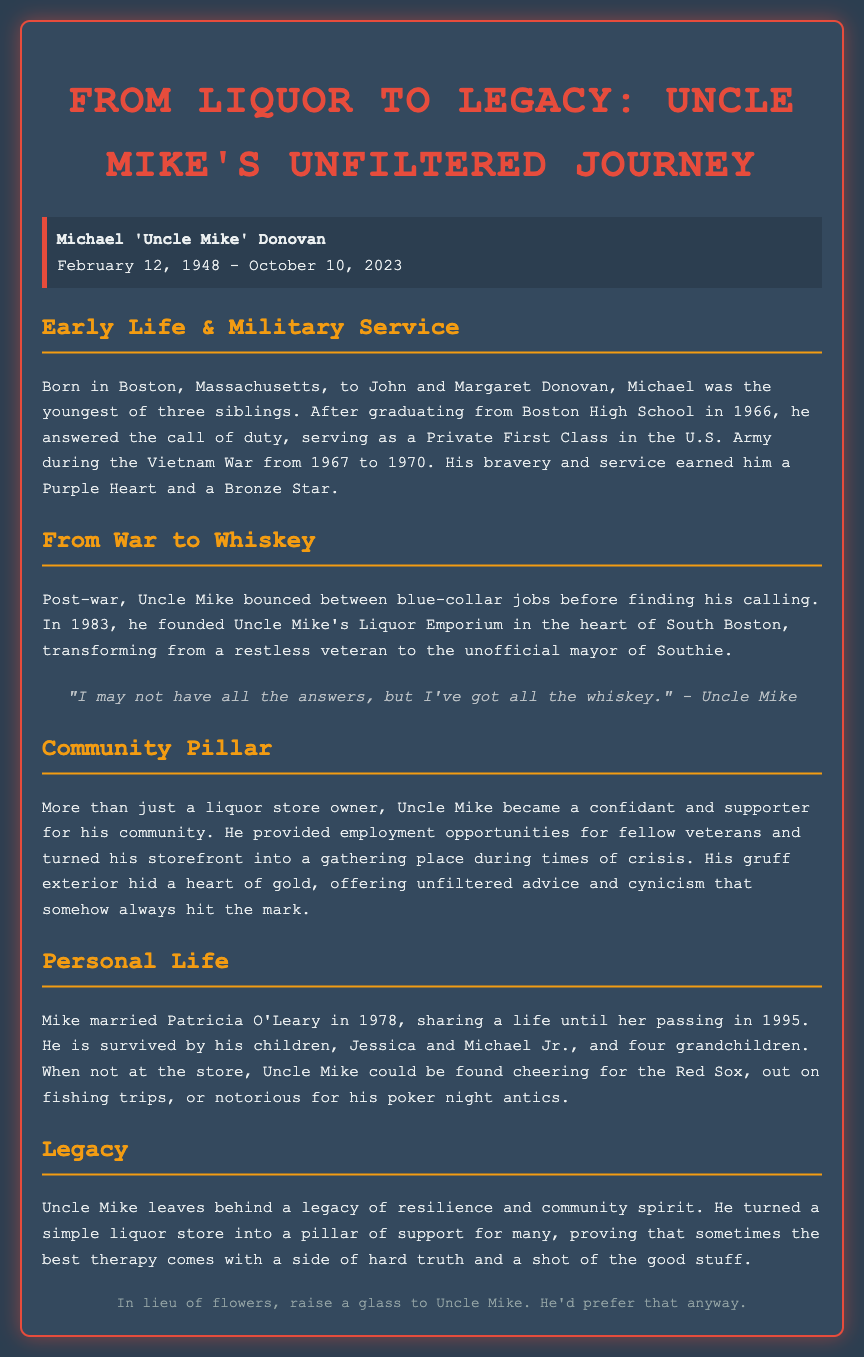What is Uncle Mike's full name? The document provides his full name as Michael 'Uncle Mike' Donovan.
Answer: Michael 'Uncle Mike' Donovan What military honors did Uncle Mike receive? The document mentions he earned a Purple Heart and a Bronze Star for his bravery during the Vietnam War.
Answer: Purple Heart and Bronze Star When was Uncle Mike born? The birth date given in the document is February 12, 1948.
Answer: February 12, 1948 What year did Uncle Mike found his liquor store? The document states that he founded Uncle Mike's Liquor Emporium in 1983.
Answer: 1983 How many grandchildren does Uncle Mike have? The document specifies that he is survived by four grandchildren.
Answer: Four What was one of Uncle Mike's notable sayings? The document quotes Uncle Mike saying, "I may not have all the answers, but I've got all the whiskey."
Answer: "I may not have all the answers, but I've got all the whiskey." What significant role did Uncle Mike play in his community? The document describes him as a confidant and supporter, providing employment and turning his store into a gathering place.
Answer: Confidant and supporter In what year did Uncle Mike's wife pass away? The document mentions Patricia O'Leary passed away in 1995.
Answer: 1995 What would Uncle Mike prefer instead of flowers? The document suggests raising a glass to Uncle Mike in lieu of flowers.
Answer: Raise a glass 